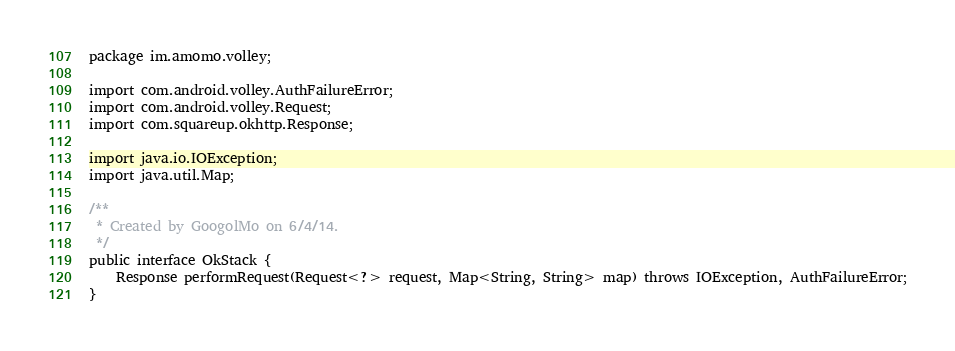Convert code to text. <code><loc_0><loc_0><loc_500><loc_500><_Java_>package im.amomo.volley;

import com.android.volley.AuthFailureError;
import com.android.volley.Request;
import com.squareup.okhttp.Response;

import java.io.IOException;
import java.util.Map;

/**
 * Created by GoogolMo on 6/4/14.
 */
public interface OkStack {
    Response performRequest(Request<?> request, Map<String, String> map) throws IOException, AuthFailureError;
}
</code> 